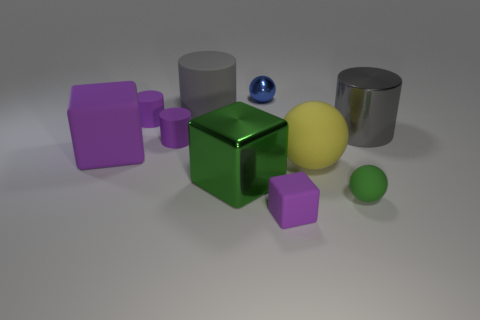What materials do the objects in the image appear to be made from? The objects in the image appear to be rendered with unique material properties. The green cube seems to have a reflective and shiny metal finish, while the purple shapes—both the cylinder and cubes—resemble rubber with a matte surface. The yellow sphere and the smaller green sphere look like they could be made of a glossy, smooth plastic. 